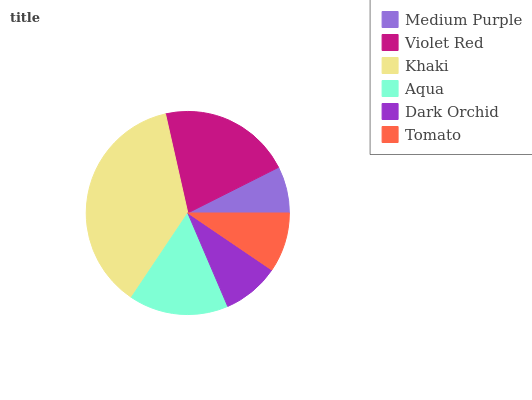Is Medium Purple the minimum?
Answer yes or no. Yes. Is Khaki the maximum?
Answer yes or no. Yes. Is Violet Red the minimum?
Answer yes or no. No. Is Violet Red the maximum?
Answer yes or no. No. Is Violet Red greater than Medium Purple?
Answer yes or no. Yes. Is Medium Purple less than Violet Red?
Answer yes or no. Yes. Is Medium Purple greater than Violet Red?
Answer yes or no. No. Is Violet Red less than Medium Purple?
Answer yes or no. No. Is Aqua the high median?
Answer yes or no. Yes. Is Tomato the low median?
Answer yes or no. Yes. Is Khaki the high median?
Answer yes or no. No. Is Khaki the low median?
Answer yes or no. No. 